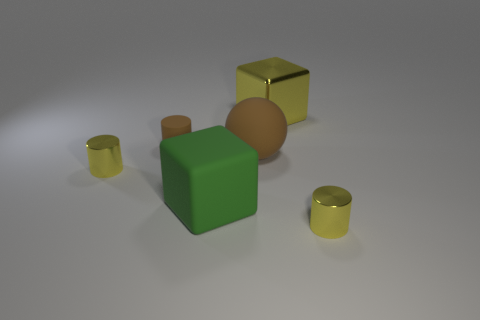Add 2 large brown metal objects. How many objects exist? 8 Subtract all balls. How many objects are left? 5 Subtract all tiny purple metal objects. Subtract all metallic cylinders. How many objects are left? 4 Add 5 tiny brown objects. How many tiny brown objects are left? 6 Add 1 tiny metallic objects. How many tiny metallic objects exist? 3 Subtract 0 gray cylinders. How many objects are left? 6 